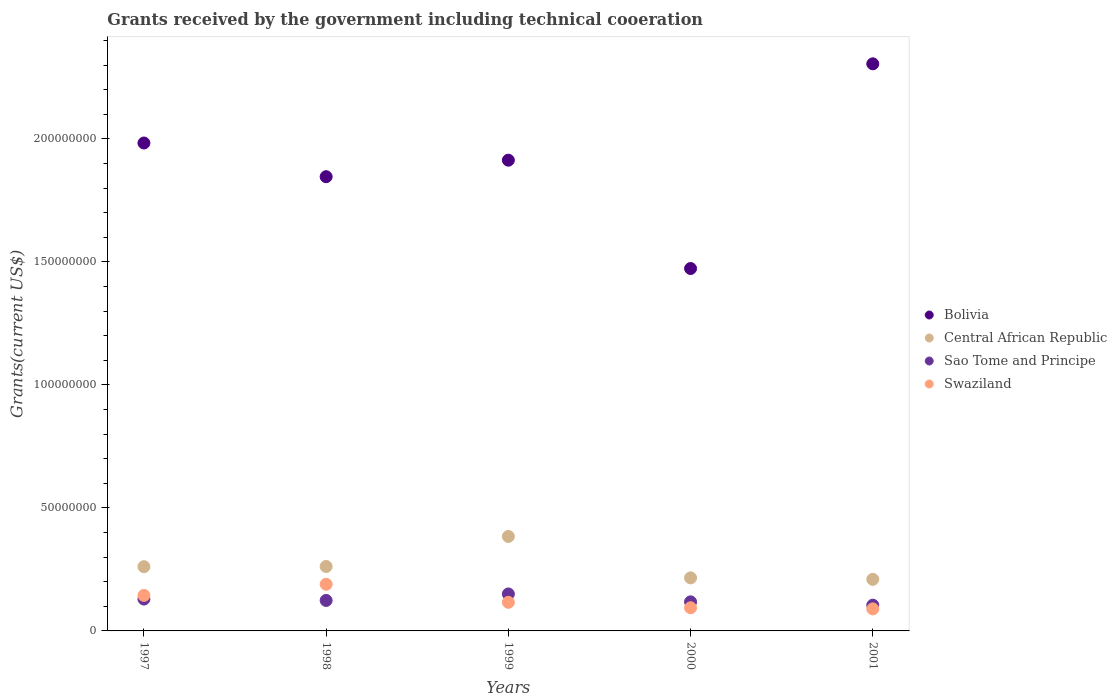What is the total grants received by the government in Swaziland in 2000?
Provide a succinct answer. 9.42e+06. Across all years, what is the maximum total grants received by the government in Central African Republic?
Your answer should be compact. 3.84e+07. Across all years, what is the minimum total grants received by the government in Swaziland?
Your answer should be very brief. 8.96e+06. In which year was the total grants received by the government in Bolivia maximum?
Provide a short and direct response. 2001. In which year was the total grants received by the government in Swaziland minimum?
Your answer should be very brief. 2001. What is the total total grants received by the government in Bolivia in the graph?
Make the answer very short. 9.52e+08. What is the difference between the total grants received by the government in Central African Republic in 1998 and that in 1999?
Offer a very short reply. -1.22e+07. What is the difference between the total grants received by the government in Swaziland in 1999 and the total grants received by the government in Bolivia in 2001?
Your response must be concise. -2.19e+08. What is the average total grants received by the government in Swaziland per year?
Make the answer very short. 1.27e+07. In the year 1999, what is the difference between the total grants received by the government in Central African Republic and total grants received by the government in Swaziland?
Your response must be concise. 2.68e+07. In how many years, is the total grants received by the government in Central African Republic greater than 50000000 US$?
Provide a short and direct response. 0. What is the ratio of the total grants received by the government in Bolivia in 1997 to that in 1998?
Offer a terse response. 1.07. What is the difference between the highest and the second highest total grants received by the government in Swaziland?
Provide a short and direct response. 4.53e+06. What is the difference between the highest and the lowest total grants received by the government in Bolivia?
Provide a succinct answer. 8.32e+07. Is the sum of the total grants received by the government in Central African Republic in 2000 and 2001 greater than the maximum total grants received by the government in Sao Tome and Principe across all years?
Your answer should be compact. Yes. Is it the case that in every year, the sum of the total grants received by the government in Bolivia and total grants received by the government in Swaziland  is greater than the sum of total grants received by the government in Central African Republic and total grants received by the government in Sao Tome and Principe?
Your response must be concise. Yes. Does the total grants received by the government in Swaziland monotonically increase over the years?
Offer a terse response. No. How many dotlines are there?
Provide a short and direct response. 4. How many years are there in the graph?
Provide a succinct answer. 5. Where does the legend appear in the graph?
Keep it short and to the point. Center right. What is the title of the graph?
Ensure brevity in your answer.  Grants received by the government including technical cooeration. Does "Netherlands" appear as one of the legend labels in the graph?
Your answer should be compact. No. What is the label or title of the Y-axis?
Offer a very short reply. Grants(current US$). What is the Grants(current US$) in Bolivia in 1997?
Provide a succinct answer. 1.98e+08. What is the Grants(current US$) in Central African Republic in 1997?
Your answer should be compact. 2.61e+07. What is the Grants(current US$) in Sao Tome and Principe in 1997?
Your response must be concise. 1.30e+07. What is the Grants(current US$) in Swaziland in 1997?
Provide a succinct answer. 1.44e+07. What is the Grants(current US$) in Bolivia in 1998?
Provide a succinct answer. 1.85e+08. What is the Grants(current US$) of Central African Republic in 1998?
Your answer should be compact. 2.62e+07. What is the Grants(current US$) of Sao Tome and Principe in 1998?
Provide a succinct answer. 1.24e+07. What is the Grants(current US$) of Swaziland in 1998?
Give a very brief answer. 1.90e+07. What is the Grants(current US$) of Bolivia in 1999?
Your response must be concise. 1.91e+08. What is the Grants(current US$) in Central African Republic in 1999?
Provide a short and direct response. 3.84e+07. What is the Grants(current US$) of Sao Tome and Principe in 1999?
Keep it short and to the point. 1.50e+07. What is the Grants(current US$) of Swaziland in 1999?
Your answer should be compact. 1.16e+07. What is the Grants(current US$) in Bolivia in 2000?
Your response must be concise. 1.47e+08. What is the Grants(current US$) of Central African Republic in 2000?
Provide a succinct answer. 2.16e+07. What is the Grants(current US$) of Sao Tome and Principe in 2000?
Provide a succinct answer. 1.18e+07. What is the Grants(current US$) of Swaziland in 2000?
Your response must be concise. 9.42e+06. What is the Grants(current US$) of Bolivia in 2001?
Your answer should be compact. 2.31e+08. What is the Grants(current US$) of Central African Republic in 2001?
Your answer should be compact. 2.10e+07. What is the Grants(current US$) in Sao Tome and Principe in 2001?
Give a very brief answer. 1.05e+07. What is the Grants(current US$) of Swaziland in 2001?
Offer a terse response. 8.96e+06. Across all years, what is the maximum Grants(current US$) of Bolivia?
Offer a terse response. 2.31e+08. Across all years, what is the maximum Grants(current US$) in Central African Republic?
Provide a short and direct response. 3.84e+07. Across all years, what is the maximum Grants(current US$) of Sao Tome and Principe?
Make the answer very short. 1.50e+07. Across all years, what is the maximum Grants(current US$) in Swaziland?
Offer a terse response. 1.90e+07. Across all years, what is the minimum Grants(current US$) of Bolivia?
Provide a short and direct response. 1.47e+08. Across all years, what is the minimum Grants(current US$) in Central African Republic?
Offer a terse response. 2.10e+07. Across all years, what is the minimum Grants(current US$) of Sao Tome and Principe?
Ensure brevity in your answer.  1.05e+07. Across all years, what is the minimum Grants(current US$) of Swaziland?
Provide a short and direct response. 8.96e+06. What is the total Grants(current US$) in Bolivia in the graph?
Give a very brief answer. 9.52e+08. What is the total Grants(current US$) in Central African Republic in the graph?
Your answer should be compact. 1.33e+08. What is the total Grants(current US$) in Sao Tome and Principe in the graph?
Give a very brief answer. 6.27e+07. What is the total Grants(current US$) of Swaziland in the graph?
Your answer should be very brief. 6.34e+07. What is the difference between the Grants(current US$) of Bolivia in 1997 and that in 1998?
Ensure brevity in your answer.  1.37e+07. What is the difference between the Grants(current US$) of Central African Republic in 1997 and that in 1998?
Keep it short and to the point. -8.00e+04. What is the difference between the Grants(current US$) of Sao Tome and Principe in 1997 and that in 1998?
Your answer should be very brief. 5.60e+05. What is the difference between the Grants(current US$) of Swaziland in 1997 and that in 1998?
Provide a succinct answer. -4.53e+06. What is the difference between the Grants(current US$) of Bolivia in 1997 and that in 1999?
Your response must be concise. 6.98e+06. What is the difference between the Grants(current US$) in Central African Republic in 1997 and that in 1999?
Your response must be concise. -1.23e+07. What is the difference between the Grants(current US$) in Sao Tome and Principe in 1997 and that in 1999?
Your response must be concise. -2.08e+06. What is the difference between the Grants(current US$) of Swaziland in 1997 and that in 1999?
Your response must be concise. 2.80e+06. What is the difference between the Grants(current US$) in Bolivia in 1997 and that in 2000?
Your response must be concise. 5.10e+07. What is the difference between the Grants(current US$) of Central African Republic in 1997 and that in 2000?
Your answer should be very brief. 4.54e+06. What is the difference between the Grants(current US$) of Sao Tome and Principe in 1997 and that in 2000?
Give a very brief answer. 1.13e+06. What is the difference between the Grants(current US$) in Swaziland in 1997 and that in 2000?
Your answer should be very brief. 5.01e+06. What is the difference between the Grants(current US$) of Bolivia in 1997 and that in 2001?
Offer a terse response. -3.22e+07. What is the difference between the Grants(current US$) in Central African Republic in 1997 and that in 2001?
Make the answer very short. 5.15e+06. What is the difference between the Grants(current US$) in Sao Tome and Principe in 1997 and that in 2001?
Ensure brevity in your answer.  2.48e+06. What is the difference between the Grants(current US$) in Swaziland in 1997 and that in 2001?
Your response must be concise. 5.47e+06. What is the difference between the Grants(current US$) in Bolivia in 1998 and that in 1999?
Give a very brief answer. -6.71e+06. What is the difference between the Grants(current US$) in Central African Republic in 1998 and that in 1999?
Your response must be concise. -1.22e+07. What is the difference between the Grants(current US$) of Sao Tome and Principe in 1998 and that in 1999?
Your response must be concise. -2.64e+06. What is the difference between the Grants(current US$) in Swaziland in 1998 and that in 1999?
Your response must be concise. 7.33e+06. What is the difference between the Grants(current US$) of Bolivia in 1998 and that in 2000?
Your answer should be very brief. 3.73e+07. What is the difference between the Grants(current US$) in Central African Republic in 1998 and that in 2000?
Your answer should be compact. 4.62e+06. What is the difference between the Grants(current US$) of Sao Tome and Principe in 1998 and that in 2000?
Provide a short and direct response. 5.70e+05. What is the difference between the Grants(current US$) of Swaziland in 1998 and that in 2000?
Your answer should be very brief. 9.54e+06. What is the difference between the Grants(current US$) of Bolivia in 1998 and that in 2001?
Offer a terse response. -4.59e+07. What is the difference between the Grants(current US$) of Central African Republic in 1998 and that in 2001?
Offer a terse response. 5.23e+06. What is the difference between the Grants(current US$) in Sao Tome and Principe in 1998 and that in 2001?
Your answer should be compact. 1.92e+06. What is the difference between the Grants(current US$) of Bolivia in 1999 and that in 2000?
Make the answer very short. 4.40e+07. What is the difference between the Grants(current US$) in Central African Republic in 1999 and that in 2000?
Provide a short and direct response. 1.68e+07. What is the difference between the Grants(current US$) of Sao Tome and Principe in 1999 and that in 2000?
Your answer should be compact. 3.21e+06. What is the difference between the Grants(current US$) in Swaziland in 1999 and that in 2000?
Your answer should be compact. 2.21e+06. What is the difference between the Grants(current US$) in Bolivia in 1999 and that in 2001?
Your answer should be very brief. -3.92e+07. What is the difference between the Grants(current US$) in Central African Republic in 1999 and that in 2001?
Offer a very short reply. 1.74e+07. What is the difference between the Grants(current US$) of Sao Tome and Principe in 1999 and that in 2001?
Offer a very short reply. 4.56e+06. What is the difference between the Grants(current US$) of Swaziland in 1999 and that in 2001?
Your answer should be very brief. 2.67e+06. What is the difference between the Grants(current US$) of Bolivia in 2000 and that in 2001?
Provide a succinct answer. -8.32e+07. What is the difference between the Grants(current US$) of Central African Republic in 2000 and that in 2001?
Your answer should be very brief. 6.10e+05. What is the difference between the Grants(current US$) of Sao Tome and Principe in 2000 and that in 2001?
Your answer should be compact. 1.35e+06. What is the difference between the Grants(current US$) of Bolivia in 1997 and the Grants(current US$) of Central African Republic in 1998?
Offer a very short reply. 1.72e+08. What is the difference between the Grants(current US$) in Bolivia in 1997 and the Grants(current US$) in Sao Tome and Principe in 1998?
Provide a short and direct response. 1.86e+08. What is the difference between the Grants(current US$) in Bolivia in 1997 and the Grants(current US$) in Swaziland in 1998?
Offer a terse response. 1.79e+08. What is the difference between the Grants(current US$) in Central African Republic in 1997 and the Grants(current US$) in Sao Tome and Principe in 1998?
Provide a succinct answer. 1.37e+07. What is the difference between the Grants(current US$) of Central African Republic in 1997 and the Grants(current US$) of Swaziland in 1998?
Provide a short and direct response. 7.15e+06. What is the difference between the Grants(current US$) of Sao Tome and Principe in 1997 and the Grants(current US$) of Swaziland in 1998?
Ensure brevity in your answer.  -6.01e+06. What is the difference between the Grants(current US$) of Bolivia in 1997 and the Grants(current US$) of Central African Republic in 1999?
Keep it short and to the point. 1.60e+08. What is the difference between the Grants(current US$) of Bolivia in 1997 and the Grants(current US$) of Sao Tome and Principe in 1999?
Offer a terse response. 1.83e+08. What is the difference between the Grants(current US$) in Bolivia in 1997 and the Grants(current US$) in Swaziland in 1999?
Your response must be concise. 1.87e+08. What is the difference between the Grants(current US$) of Central African Republic in 1997 and the Grants(current US$) of Sao Tome and Principe in 1999?
Give a very brief answer. 1.11e+07. What is the difference between the Grants(current US$) of Central African Republic in 1997 and the Grants(current US$) of Swaziland in 1999?
Keep it short and to the point. 1.45e+07. What is the difference between the Grants(current US$) of Sao Tome and Principe in 1997 and the Grants(current US$) of Swaziland in 1999?
Your response must be concise. 1.32e+06. What is the difference between the Grants(current US$) in Bolivia in 1997 and the Grants(current US$) in Central African Republic in 2000?
Your answer should be compact. 1.77e+08. What is the difference between the Grants(current US$) of Bolivia in 1997 and the Grants(current US$) of Sao Tome and Principe in 2000?
Ensure brevity in your answer.  1.87e+08. What is the difference between the Grants(current US$) in Bolivia in 1997 and the Grants(current US$) in Swaziland in 2000?
Provide a succinct answer. 1.89e+08. What is the difference between the Grants(current US$) of Central African Republic in 1997 and the Grants(current US$) of Sao Tome and Principe in 2000?
Make the answer very short. 1.43e+07. What is the difference between the Grants(current US$) of Central African Republic in 1997 and the Grants(current US$) of Swaziland in 2000?
Give a very brief answer. 1.67e+07. What is the difference between the Grants(current US$) in Sao Tome and Principe in 1997 and the Grants(current US$) in Swaziland in 2000?
Make the answer very short. 3.53e+06. What is the difference between the Grants(current US$) in Bolivia in 1997 and the Grants(current US$) in Central African Republic in 2001?
Your answer should be very brief. 1.77e+08. What is the difference between the Grants(current US$) in Bolivia in 1997 and the Grants(current US$) in Sao Tome and Principe in 2001?
Your response must be concise. 1.88e+08. What is the difference between the Grants(current US$) of Bolivia in 1997 and the Grants(current US$) of Swaziland in 2001?
Ensure brevity in your answer.  1.89e+08. What is the difference between the Grants(current US$) of Central African Republic in 1997 and the Grants(current US$) of Sao Tome and Principe in 2001?
Offer a terse response. 1.56e+07. What is the difference between the Grants(current US$) of Central African Republic in 1997 and the Grants(current US$) of Swaziland in 2001?
Make the answer very short. 1.72e+07. What is the difference between the Grants(current US$) in Sao Tome and Principe in 1997 and the Grants(current US$) in Swaziland in 2001?
Your response must be concise. 3.99e+06. What is the difference between the Grants(current US$) in Bolivia in 1998 and the Grants(current US$) in Central African Republic in 1999?
Keep it short and to the point. 1.46e+08. What is the difference between the Grants(current US$) of Bolivia in 1998 and the Grants(current US$) of Sao Tome and Principe in 1999?
Ensure brevity in your answer.  1.70e+08. What is the difference between the Grants(current US$) of Bolivia in 1998 and the Grants(current US$) of Swaziland in 1999?
Keep it short and to the point. 1.73e+08. What is the difference between the Grants(current US$) of Central African Republic in 1998 and the Grants(current US$) of Sao Tome and Principe in 1999?
Keep it short and to the point. 1.12e+07. What is the difference between the Grants(current US$) of Central African Republic in 1998 and the Grants(current US$) of Swaziland in 1999?
Keep it short and to the point. 1.46e+07. What is the difference between the Grants(current US$) in Sao Tome and Principe in 1998 and the Grants(current US$) in Swaziland in 1999?
Your answer should be very brief. 7.60e+05. What is the difference between the Grants(current US$) in Bolivia in 1998 and the Grants(current US$) in Central African Republic in 2000?
Offer a very short reply. 1.63e+08. What is the difference between the Grants(current US$) in Bolivia in 1998 and the Grants(current US$) in Sao Tome and Principe in 2000?
Ensure brevity in your answer.  1.73e+08. What is the difference between the Grants(current US$) in Bolivia in 1998 and the Grants(current US$) in Swaziland in 2000?
Keep it short and to the point. 1.75e+08. What is the difference between the Grants(current US$) of Central African Republic in 1998 and the Grants(current US$) of Sao Tome and Principe in 2000?
Provide a short and direct response. 1.44e+07. What is the difference between the Grants(current US$) in Central African Republic in 1998 and the Grants(current US$) in Swaziland in 2000?
Give a very brief answer. 1.68e+07. What is the difference between the Grants(current US$) in Sao Tome and Principe in 1998 and the Grants(current US$) in Swaziland in 2000?
Your answer should be compact. 2.97e+06. What is the difference between the Grants(current US$) of Bolivia in 1998 and the Grants(current US$) of Central African Republic in 2001?
Your answer should be very brief. 1.64e+08. What is the difference between the Grants(current US$) in Bolivia in 1998 and the Grants(current US$) in Sao Tome and Principe in 2001?
Ensure brevity in your answer.  1.74e+08. What is the difference between the Grants(current US$) in Bolivia in 1998 and the Grants(current US$) in Swaziland in 2001?
Your answer should be very brief. 1.76e+08. What is the difference between the Grants(current US$) in Central African Republic in 1998 and the Grants(current US$) in Sao Tome and Principe in 2001?
Give a very brief answer. 1.57e+07. What is the difference between the Grants(current US$) in Central African Republic in 1998 and the Grants(current US$) in Swaziland in 2001?
Offer a very short reply. 1.72e+07. What is the difference between the Grants(current US$) of Sao Tome and Principe in 1998 and the Grants(current US$) of Swaziland in 2001?
Offer a terse response. 3.43e+06. What is the difference between the Grants(current US$) in Bolivia in 1999 and the Grants(current US$) in Central African Republic in 2000?
Provide a succinct answer. 1.70e+08. What is the difference between the Grants(current US$) of Bolivia in 1999 and the Grants(current US$) of Sao Tome and Principe in 2000?
Your answer should be very brief. 1.80e+08. What is the difference between the Grants(current US$) in Bolivia in 1999 and the Grants(current US$) in Swaziland in 2000?
Provide a succinct answer. 1.82e+08. What is the difference between the Grants(current US$) in Central African Republic in 1999 and the Grants(current US$) in Sao Tome and Principe in 2000?
Your response must be concise. 2.66e+07. What is the difference between the Grants(current US$) of Central African Republic in 1999 and the Grants(current US$) of Swaziland in 2000?
Your answer should be very brief. 2.90e+07. What is the difference between the Grants(current US$) in Sao Tome and Principe in 1999 and the Grants(current US$) in Swaziland in 2000?
Provide a succinct answer. 5.61e+06. What is the difference between the Grants(current US$) of Bolivia in 1999 and the Grants(current US$) of Central African Republic in 2001?
Make the answer very short. 1.70e+08. What is the difference between the Grants(current US$) of Bolivia in 1999 and the Grants(current US$) of Sao Tome and Principe in 2001?
Offer a terse response. 1.81e+08. What is the difference between the Grants(current US$) in Bolivia in 1999 and the Grants(current US$) in Swaziland in 2001?
Make the answer very short. 1.82e+08. What is the difference between the Grants(current US$) of Central African Republic in 1999 and the Grants(current US$) of Sao Tome and Principe in 2001?
Offer a terse response. 2.79e+07. What is the difference between the Grants(current US$) in Central African Republic in 1999 and the Grants(current US$) in Swaziland in 2001?
Your response must be concise. 2.94e+07. What is the difference between the Grants(current US$) of Sao Tome and Principe in 1999 and the Grants(current US$) of Swaziland in 2001?
Your response must be concise. 6.07e+06. What is the difference between the Grants(current US$) of Bolivia in 2000 and the Grants(current US$) of Central African Republic in 2001?
Your answer should be compact. 1.26e+08. What is the difference between the Grants(current US$) of Bolivia in 2000 and the Grants(current US$) of Sao Tome and Principe in 2001?
Offer a very short reply. 1.37e+08. What is the difference between the Grants(current US$) of Bolivia in 2000 and the Grants(current US$) of Swaziland in 2001?
Keep it short and to the point. 1.38e+08. What is the difference between the Grants(current US$) in Central African Republic in 2000 and the Grants(current US$) in Sao Tome and Principe in 2001?
Provide a succinct answer. 1.11e+07. What is the difference between the Grants(current US$) in Central African Republic in 2000 and the Grants(current US$) in Swaziland in 2001?
Keep it short and to the point. 1.26e+07. What is the difference between the Grants(current US$) of Sao Tome and Principe in 2000 and the Grants(current US$) of Swaziland in 2001?
Your answer should be compact. 2.86e+06. What is the average Grants(current US$) in Bolivia per year?
Provide a succinct answer. 1.90e+08. What is the average Grants(current US$) in Central African Republic per year?
Keep it short and to the point. 2.66e+07. What is the average Grants(current US$) in Sao Tome and Principe per year?
Offer a terse response. 1.25e+07. What is the average Grants(current US$) of Swaziland per year?
Provide a succinct answer. 1.27e+07. In the year 1997, what is the difference between the Grants(current US$) in Bolivia and Grants(current US$) in Central African Republic?
Your answer should be very brief. 1.72e+08. In the year 1997, what is the difference between the Grants(current US$) in Bolivia and Grants(current US$) in Sao Tome and Principe?
Offer a terse response. 1.85e+08. In the year 1997, what is the difference between the Grants(current US$) of Bolivia and Grants(current US$) of Swaziland?
Offer a terse response. 1.84e+08. In the year 1997, what is the difference between the Grants(current US$) of Central African Republic and Grants(current US$) of Sao Tome and Principe?
Make the answer very short. 1.32e+07. In the year 1997, what is the difference between the Grants(current US$) of Central African Republic and Grants(current US$) of Swaziland?
Provide a succinct answer. 1.17e+07. In the year 1997, what is the difference between the Grants(current US$) in Sao Tome and Principe and Grants(current US$) in Swaziland?
Make the answer very short. -1.48e+06. In the year 1998, what is the difference between the Grants(current US$) of Bolivia and Grants(current US$) of Central African Republic?
Give a very brief answer. 1.58e+08. In the year 1998, what is the difference between the Grants(current US$) of Bolivia and Grants(current US$) of Sao Tome and Principe?
Your answer should be very brief. 1.72e+08. In the year 1998, what is the difference between the Grants(current US$) in Bolivia and Grants(current US$) in Swaziland?
Provide a succinct answer. 1.66e+08. In the year 1998, what is the difference between the Grants(current US$) of Central African Republic and Grants(current US$) of Sao Tome and Principe?
Your response must be concise. 1.38e+07. In the year 1998, what is the difference between the Grants(current US$) of Central African Republic and Grants(current US$) of Swaziland?
Your answer should be compact. 7.23e+06. In the year 1998, what is the difference between the Grants(current US$) of Sao Tome and Principe and Grants(current US$) of Swaziland?
Ensure brevity in your answer.  -6.57e+06. In the year 1999, what is the difference between the Grants(current US$) of Bolivia and Grants(current US$) of Central African Republic?
Offer a terse response. 1.53e+08. In the year 1999, what is the difference between the Grants(current US$) of Bolivia and Grants(current US$) of Sao Tome and Principe?
Ensure brevity in your answer.  1.76e+08. In the year 1999, what is the difference between the Grants(current US$) of Bolivia and Grants(current US$) of Swaziland?
Ensure brevity in your answer.  1.80e+08. In the year 1999, what is the difference between the Grants(current US$) of Central African Republic and Grants(current US$) of Sao Tome and Principe?
Provide a short and direct response. 2.34e+07. In the year 1999, what is the difference between the Grants(current US$) of Central African Republic and Grants(current US$) of Swaziland?
Your answer should be compact. 2.68e+07. In the year 1999, what is the difference between the Grants(current US$) in Sao Tome and Principe and Grants(current US$) in Swaziland?
Offer a terse response. 3.40e+06. In the year 2000, what is the difference between the Grants(current US$) of Bolivia and Grants(current US$) of Central African Republic?
Your response must be concise. 1.26e+08. In the year 2000, what is the difference between the Grants(current US$) of Bolivia and Grants(current US$) of Sao Tome and Principe?
Your response must be concise. 1.36e+08. In the year 2000, what is the difference between the Grants(current US$) of Bolivia and Grants(current US$) of Swaziland?
Keep it short and to the point. 1.38e+08. In the year 2000, what is the difference between the Grants(current US$) of Central African Republic and Grants(current US$) of Sao Tome and Principe?
Provide a short and direct response. 9.75e+06. In the year 2000, what is the difference between the Grants(current US$) of Central African Republic and Grants(current US$) of Swaziland?
Your answer should be compact. 1.22e+07. In the year 2000, what is the difference between the Grants(current US$) in Sao Tome and Principe and Grants(current US$) in Swaziland?
Provide a succinct answer. 2.40e+06. In the year 2001, what is the difference between the Grants(current US$) of Bolivia and Grants(current US$) of Central African Republic?
Your answer should be very brief. 2.10e+08. In the year 2001, what is the difference between the Grants(current US$) of Bolivia and Grants(current US$) of Sao Tome and Principe?
Give a very brief answer. 2.20e+08. In the year 2001, what is the difference between the Grants(current US$) in Bolivia and Grants(current US$) in Swaziland?
Your answer should be compact. 2.22e+08. In the year 2001, what is the difference between the Grants(current US$) of Central African Republic and Grants(current US$) of Sao Tome and Principe?
Make the answer very short. 1.05e+07. In the year 2001, what is the difference between the Grants(current US$) in Central African Republic and Grants(current US$) in Swaziland?
Offer a terse response. 1.20e+07. In the year 2001, what is the difference between the Grants(current US$) in Sao Tome and Principe and Grants(current US$) in Swaziland?
Offer a terse response. 1.51e+06. What is the ratio of the Grants(current US$) in Bolivia in 1997 to that in 1998?
Provide a succinct answer. 1.07. What is the ratio of the Grants(current US$) in Sao Tome and Principe in 1997 to that in 1998?
Provide a short and direct response. 1.05. What is the ratio of the Grants(current US$) in Swaziland in 1997 to that in 1998?
Give a very brief answer. 0.76. What is the ratio of the Grants(current US$) of Bolivia in 1997 to that in 1999?
Offer a very short reply. 1.04. What is the ratio of the Grants(current US$) in Central African Republic in 1997 to that in 1999?
Your answer should be very brief. 0.68. What is the ratio of the Grants(current US$) in Sao Tome and Principe in 1997 to that in 1999?
Offer a terse response. 0.86. What is the ratio of the Grants(current US$) of Swaziland in 1997 to that in 1999?
Ensure brevity in your answer.  1.24. What is the ratio of the Grants(current US$) of Bolivia in 1997 to that in 2000?
Make the answer very short. 1.35. What is the ratio of the Grants(current US$) in Central African Republic in 1997 to that in 2000?
Your answer should be compact. 1.21. What is the ratio of the Grants(current US$) in Sao Tome and Principe in 1997 to that in 2000?
Provide a short and direct response. 1.1. What is the ratio of the Grants(current US$) of Swaziland in 1997 to that in 2000?
Your answer should be compact. 1.53. What is the ratio of the Grants(current US$) of Bolivia in 1997 to that in 2001?
Your response must be concise. 0.86. What is the ratio of the Grants(current US$) of Central African Republic in 1997 to that in 2001?
Ensure brevity in your answer.  1.25. What is the ratio of the Grants(current US$) of Sao Tome and Principe in 1997 to that in 2001?
Provide a short and direct response. 1.24. What is the ratio of the Grants(current US$) in Swaziland in 1997 to that in 2001?
Your answer should be very brief. 1.61. What is the ratio of the Grants(current US$) in Bolivia in 1998 to that in 1999?
Provide a short and direct response. 0.96. What is the ratio of the Grants(current US$) in Central African Republic in 1998 to that in 1999?
Your answer should be compact. 0.68. What is the ratio of the Grants(current US$) in Sao Tome and Principe in 1998 to that in 1999?
Your response must be concise. 0.82. What is the ratio of the Grants(current US$) of Swaziland in 1998 to that in 1999?
Give a very brief answer. 1.63. What is the ratio of the Grants(current US$) of Bolivia in 1998 to that in 2000?
Your answer should be compact. 1.25. What is the ratio of the Grants(current US$) of Central African Republic in 1998 to that in 2000?
Make the answer very short. 1.21. What is the ratio of the Grants(current US$) in Sao Tome and Principe in 1998 to that in 2000?
Make the answer very short. 1.05. What is the ratio of the Grants(current US$) of Swaziland in 1998 to that in 2000?
Offer a terse response. 2.01. What is the ratio of the Grants(current US$) of Bolivia in 1998 to that in 2001?
Your answer should be compact. 0.8. What is the ratio of the Grants(current US$) in Central African Republic in 1998 to that in 2001?
Ensure brevity in your answer.  1.25. What is the ratio of the Grants(current US$) in Sao Tome and Principe in 1998 to that in 2001?
Provide a short and direct response. 1.18. What is the ratio of the Grants(current US$) of Swaziland in 1998 to that in 2001?
Make the answer very short. 2.12. What is the ratio of the Grants(current US$) in Bolivia in 1999 to that in 2000?
Ensure brevity in your answer.  1.3. What is the ratio of the Grants(current US$) in Central African Republic in 1999 to that in 2000?
Make the answer very short. 1.78. What is the ratio of the Grants(current US$) of Sao Tome and Principe in 1999 to that in 2000?
Keep it short and to the point. 1.27. What is the ratio of the Grants(current US$) of Swaziland in 1999 to that in 2000?
Offer a very short reply. 1.23. What is the ratio of the Grants(current US$) of Bolivia in 1999 to that in 2001?
Ensure brevity in your answer.  0.83. What is the ratio of the Grants(current US$) in Central African Republic in 1999 to that in 2001?
Ensure brevity in your answer.  1.83. What is the ratio of the Grants(current US$) in Sao Tome and Principe in 1999 to that in 2001?
Your response must be concise. 1.44. What is the ratio of the Grants(current US$) of Swaziland in 1999 to that in 2001?
Your answer should be very brief. 1.3. What is the ratio of the Grants(current US$) of Bolivia in 2000 to that in 2001?
Provide a short and direct response. 0.64. What is the ratio of the Grants(current US$) of Central African Republic in 2000 to that in 2001?
Make the answer very short. 1.03. What is the ratio of the Grants(current US$) in Sao Tome and Principe in 2000 to that in 2001?
Your response must be concise. 1.13. What is the ratio of the Grants(current US$) of Swaziland in 2000 to that in 2001?
Give a very brief answer. 1.05. What is the difference between the highest and the second highest Grants(current US$) of Bolivia?
Provide a succinct answer. 3.22e+07. What is the difference between the highest and the second highest Grants(current US$) in Central African Republic?
Offer a terse response. 1.22e+07. What is the difference between the highest and the second highest Grants(current US$) in Sao Tome and Principe?
Keep it short and to the point. 2.08e+06. What is the difference between the highest and the second highest Grants(current US$) in Swaziland?
Offer a very short reply. 4.53e+06. What is the difference between the highest and the lowest Grants(current US$) in Bolivia?
Make the answer very short. 8.32e+07. What is the difference between the highest and the lowest Grants(current US$) in Central African Republic?
Provide a short and direct response. 1.74e+07. What is the difference between the highest and the lowest Grants(current US$) of Sao Tome and Principe?
Your response must be concise. 4.56e+06. 